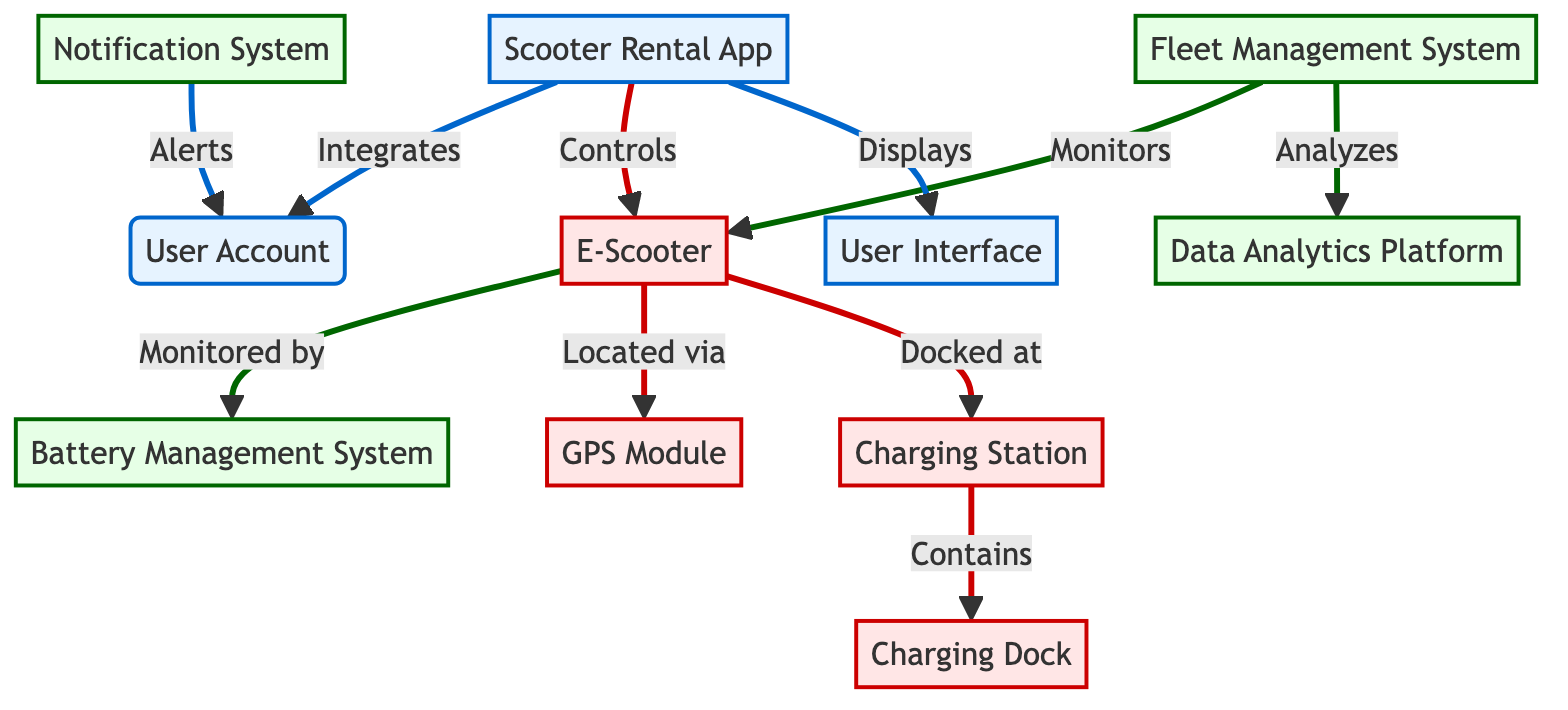What is the primary function of the Scooter Rental App? The Scooter Rental App is primarily used to locate, rent, and pay for e-scooter rides as indicated at the diagram's topmost element.
Answer: Locate, rent, and pay How many physical components are present in the diagram? The diagram includes four physical components: E-Scooter, Charging Station, Charging Dock, and GPS Module, identified as hardware elements.
Answer: Four Which system monitors the battery status of the e-scooter? The Battery Management System, represented in the diagram, directly monitors battery status and performance within the e-scooter.
Answer: Battery Management System What does the Fleet Management System analyze? The Fleet Management System analyzes data gathered by the Data Analytics Platform to optimize operations, as depicted by the connection between these two elements.
Answer: Data Which component is responsible for sending alerts to users? The Notification System sends alerts, as represented in the diagram, indicating its specific function related to user communication.
Answer: Notification System What flows from the Scooter Rental App to the User Account? The diagram indicates that integration occurs from the Scooter Rental App to the User Account, highlighting their relationship.
Answer: Integrates Where do the e-scooters get charged? E-scooters are charged at Charging Stations, which are clearly shown as the designated locations for recharging in the diagram.
Answer: Charging Stations Which element directly interacts with the User Interface? The Scooter Rental App displays information through the User Interface, establishing a direct connection as indicated in the diagram.
Answer: User Interface Which two systems are connected by the analysis of data? The Fleet Management System and the Data Analytics Platform are interconnected as the Fleet Management System analyzes the data provided by the Data Analytics Platform.
Answer: Fleet Management System and Data Analytics Platform 